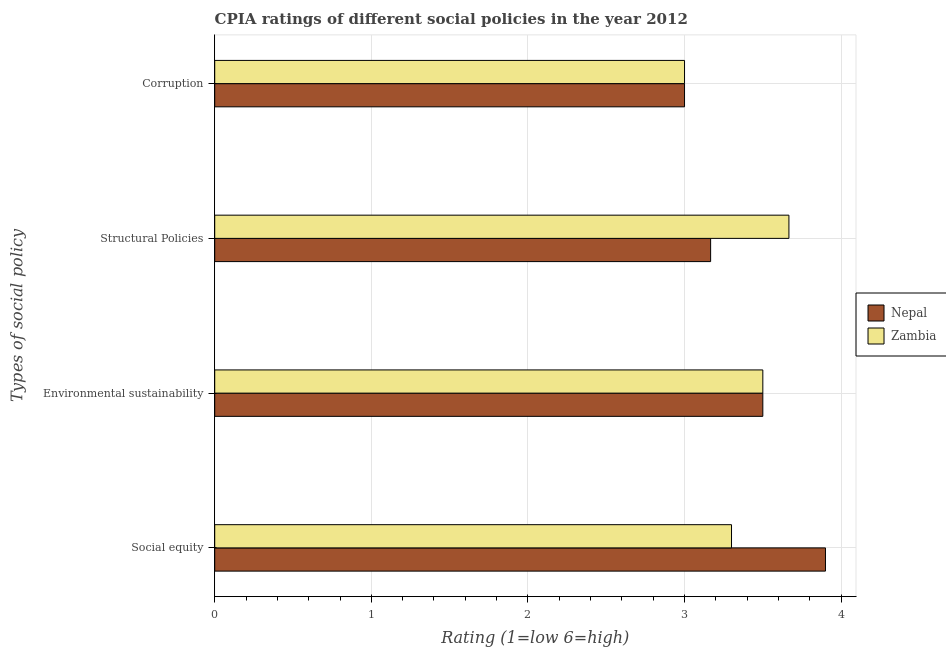How many groups of bars are there?
Keep it short and to the point. 4. Are the number of bars per tick equal to the number of legend labels?
Keep it short and to the point. Yes. How many bars are there on the 1st tick from the top?
Give a very brief answer. 2. How many bars are there on the 2nd tick from the bottom?
Offer a very short reply. 2. What is the label of the 2nd group of bars from the top?
Your response must be concise. Structural Policies. What is the cpia rating of structural policies in Zambia?
Provide a succinct answer. 3.67. Across all countries, what is the maximum cpia rating of corruption?
Your answer should be very brief. 3. In which country was the cpia rating of structural policies maximum?
Make the answer very short. Zambia. In which country was the cpia rating of social equity minimum?
Your answer should be very brief. Zambia. What is the total cpia rating of structural policies in the graph?
Your response must be concise. 6.83. What is the difference between the cpia rating of social equity in Zambia and the cpia rating of structural policies in Nepal?
Your response must be concise. 0.13. What is the average cpia rating of structural policies per country?
Provide a succinct answer. 3.42. What is the difference between the cpia rating of structural policies and cpia rating of social equity in Zambia?
Keep it short and to the point. 0.37. Is the cpia rating of environmental sustainability in Nepal less than that in Zambia?
Your answer should be compact. No. What is the difference between the highest and the second highest cpia rating of environmental sustainability?
Make the answer very short. 0. Is it the case that in every country, the sum of the cpia rating of corruption and cpia rating of social equity is greater than the sum of cpia rating of structural policies and cpia rating of environmental sustainability?
Offer a terse response. No. What does the 2nd bar from the top in Corruption represents?
Your answer should be very brief. Nepal. What does the 1st bar from the bottom in Corruption represents?
Your answer should be very brief. Nepal. Is it the case that in every country, the sum of the cpia rating of social equity and cpia rating of environmental sustainability is greater than the cpia rating of structural policies?
Offer a very short reply. Yes. Are all the bars in the graph horizontal?
Offer a very short reply. Yes. What is the difference between two consecutive major ticks on the X-axis?
Give a very brief answer. 1. Does the graph contain grids?
Ensure brevity in your answer.  Yes. Where does the legend appear in the graph?
Make the answer very short. Center right. How many legend labels are there?
Offer a very short reply. 2. How are the legend labels stacked?
Your answer should be very brief. Vertical. What is the title of the graph?
Your answer should be compact. CPIA ratings of different social policies in the year 2012. What is the label or title of the Y-axis?
Offer a terse response. Types of social policy. What is the Rating (1=low 6=high) in Nepal in Social equity?
Make the answer very short. 3.9. What is the Rating (1=low 6=high) of Nepal in Structural Policies?
Keep it short and to the point. 3.17. What is the Rating (1=low 6=high) in Zambia in Structural Policies?
Make the answer very short. 3.67. What is the Rating (1=low 6=high) of Zambia in Corruption?
Your answer should be very brief. 3. Across all Types of social policy, what is the maximum Rating (1=low 6=high) of Zambia?
Offer a terse response. 3.67. Across all Types of social policy, what is the minimum Rating (1=low 6=high) of Nepal?
Offer a very short reply. 3. What is the total Rating (1=low 6=high) in Nepal in the graph?
Offer a terse response. 13.57. What is the total Rating (1=low 6=high) of Zambia in the graph?
Give a very brief answer. 13.47. What is the difference between the Rating (1=low 6=high) in Nepal in Social equity and that in Structural Policies?
Your answer should be very brief. 0.73. What is the difference between the Rating (1=low 6=high) of Zambia in Social equity and that in Structural Policies?
Your answer should be very brief. -0.37. What is the difference between the Rating (1=low 6=high) of Nepal in Social equity and that in Corruption?
Make the answer very short. 0.9. What is the difference between the Rating (1=low 6=high) of Nepal in Environmental sustainability and that in Structural Policies?
Your answer should be compact. 0.33. What is the difference between the Rating (1=low 6=high) in Zambia in Environmental sustainability and that in Corruption?
Your response must be concise. 0.5. What is the difference between the Rating (1=low 6=high) in Nepal in Structural Policies and that in Corruption?
Make the answer very short. 0.17. What is the difference between the Rating (1=low 6=high) in Nepal in Social equity and the Rating (1=low 6=high) in Zambia in Structural Policies?
Ensure brevity in your answer.  0.23. What is the difference between the Rating (1=low 6=high) of Nepal in Social equity and the Rating (1=low 6=high) of Zambia in Corruption?
Offer a terse response. 0.9. What is the difference between the Rating (1=low 6=high) of Nepal in Environmental sustainability and the Rating (1=low 6=high) of Zambia in Corruption?
Offer a terse response. 0.5. What is the average Rating (1=low 6=high) of Nepal per Types of social policy?
Offer a very short reply. 3.39. What is the average Rating (1=low 6=high) of Zambia per Types of social policy?
Offer a terse response. 3.37. What is the difference between the Rating (1=low 6=high) in Nepal and Rating (1=low 6=high) in Zambia in Environmental sustainability?
Keep it short and to the point. 0. What is the difference between the Rating (1=low 6=high) of Nepal and Rating (1=low 6=high) of Zambia in Structural Policies?
Offer a terse response. -0.5. What is the difference between the Rating (1=low 6=high) of Nepal and Rating (1=low 6=high) of Zambia in Corruption?
Make the answer very short. 0. What is the ratio of the Rating (1=low 6=high) in Nepal in Social equity to that in Environmental sustainability?
Offer a very short reply. 1.11. What is the ratio of the Rating (1=low 6=high) in Zambia in Social equity to that in Environmental sustainability?
Provide a short and direct response. 0.94. What is the ratio of the Rating (1=low 6=high) in Nepal in Social equity to that in Structural Policies?
Give a very brief answer. 1.23. What is the ratio of the Rating (1=low 6=high) in Zambia in Social equity to that in Structural Policies?
Provide a succinct answer. 0.9. What is the ratio of the Rating (1=low 6=high) of Nepal in Environmental sustainability to that in Structural Policies?
Offer a terse response. 1.11. What is the ratio of the Rating (1=low 6=high) in Zambia in Environmental sustainability to that in Structural Policies?
Provide a succinct answer. 0.95. What is the ratio of the Rating (1=low 6=high) of Nepal in Environmental sustainability to that in Corruption?
Provide a succinct answer. 1.17. What is the ratio of the Rating (1=low 6=high) of Zambia in Environmental sustainability to that in Corruption?
Offer a terse response. 1.17. What is the ratio of the Rating (1=low 6=high) in Nepal in Structural Policies to that in Corruption?
Make the answer very short. 1.06. What is the ratio of the Rating (1=low 6=high) of Zambia in Structural Policies to that in Corruption?
Your answer should be very brief. 1.22. What is the difference between the highest and the second highest Rating (1=low 6=high) of Nepal?
Give a very brief answer. 0.4. What is the difference between the highest and the lowest Rating (1=low 6=high) of Nepal?
Offer a terse response. 0.9. What is the difference between the highest and the lowest Rating (1=low 6=high) in Zambia?
Your answer should be very brief. 0.67. 